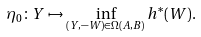<formula> <loc_0><loc_0><loc_500><loc_500>\eta _ { 0 } \colon Y \mapsto \inf _ { ( Y , - W ) \in \Omega ( A , B ) } h ^ { * } ( W ) .</formula> 